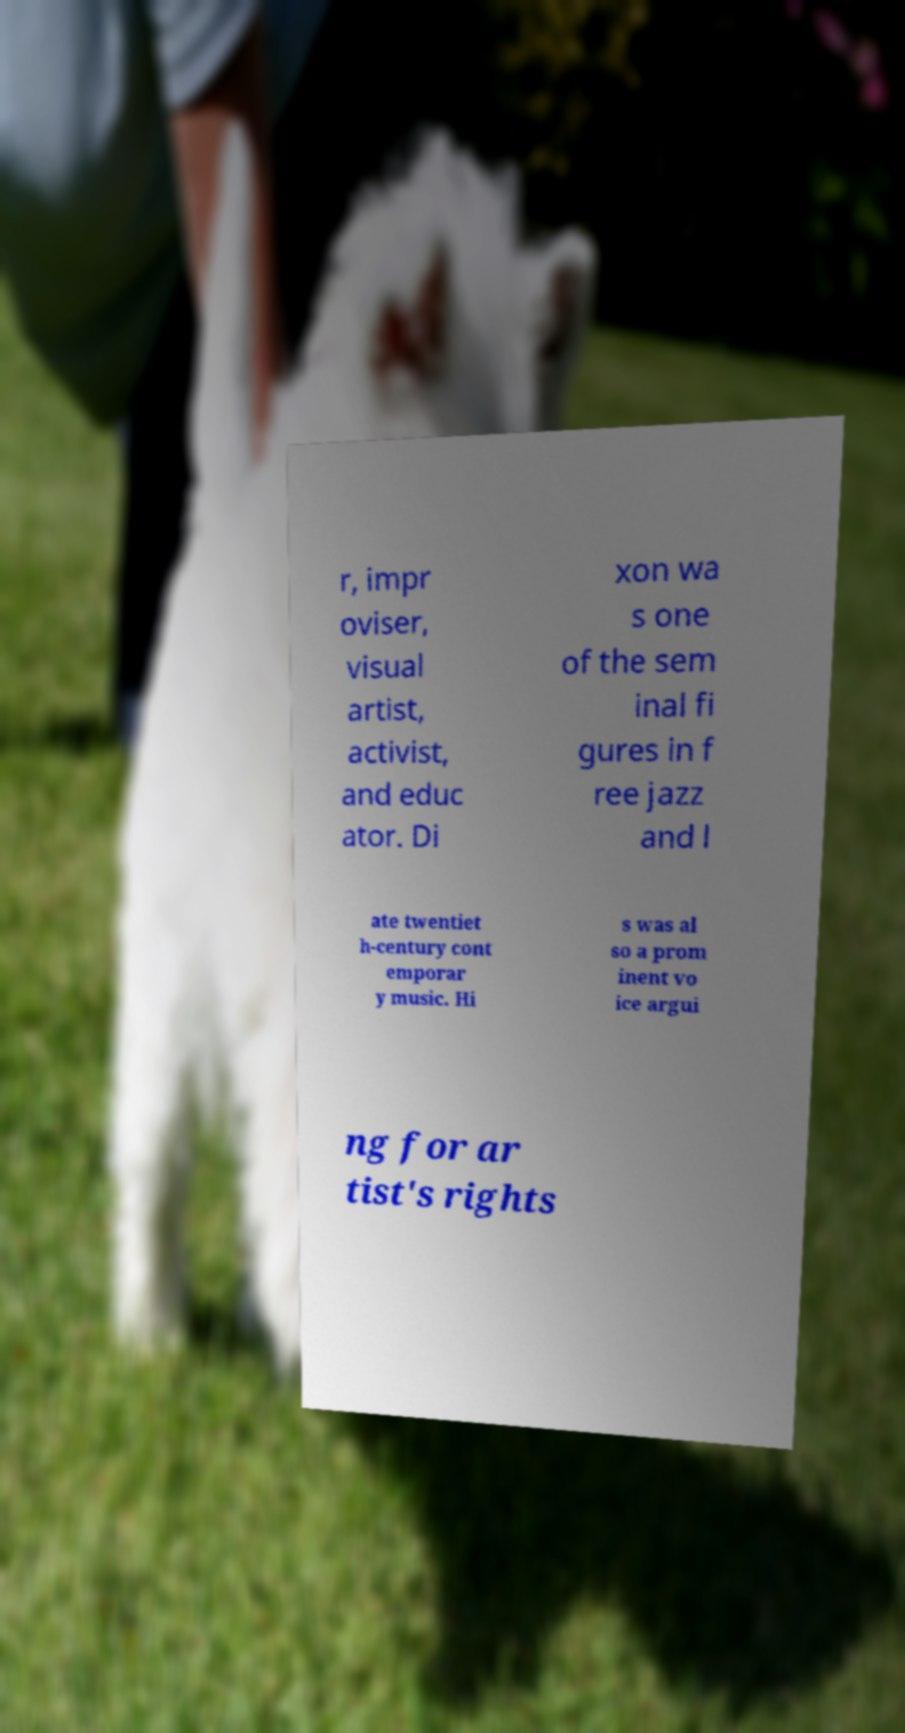There's text embedded in this image that I need extracted. Can you transcribe it verbatim? r, impr oviser, visual artist, activist, and educ ator. Di xon wa s one of the sem inal fi gures in f ree jazz and l ate twentiet h-century cont emporar y music. Hi s was al so a prom inent vo ice argui ng for ar tist's rights 